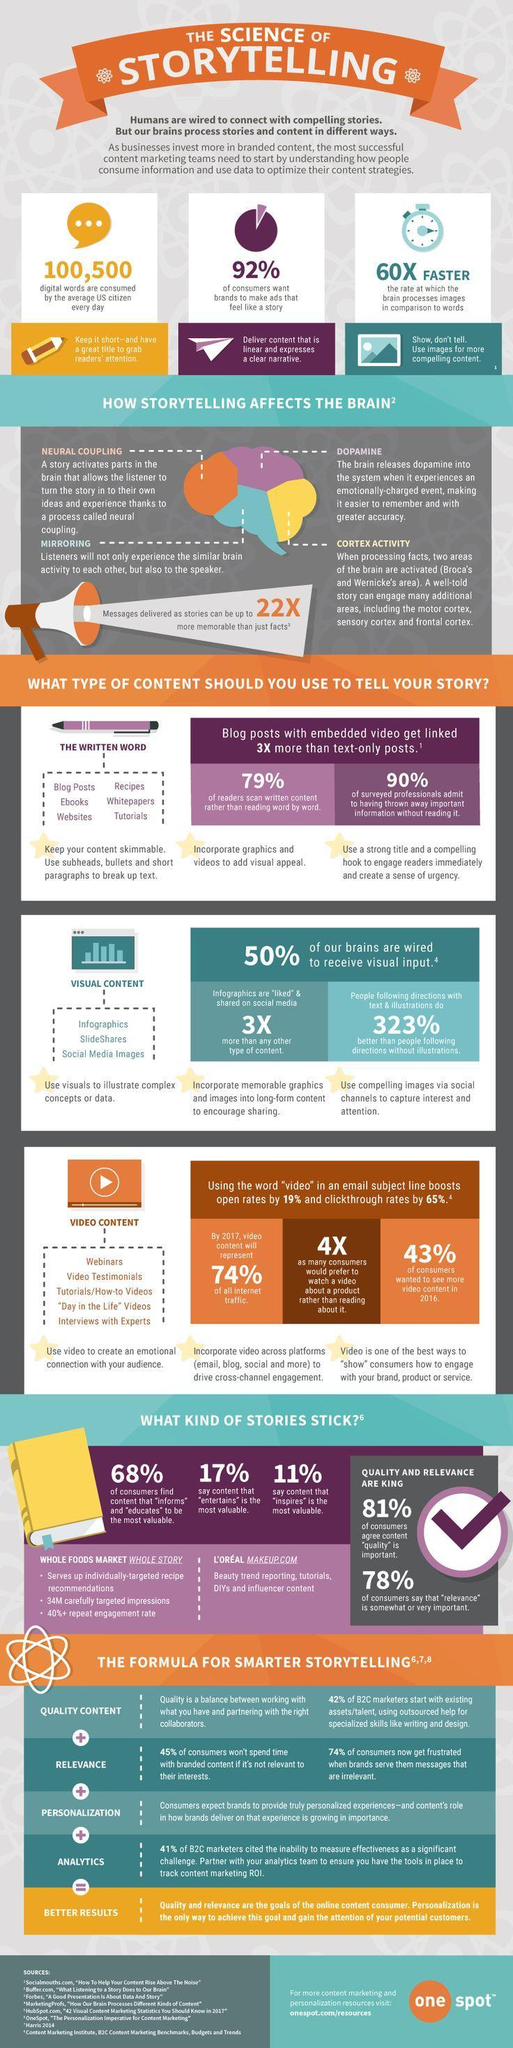Which hormone is released by story telling, Cortex, Neural, or Dopamine?
Answer the question with a short phrase. Dopamine Which content is bound to attract more users, written content, visual content, or video content? video content What percentage of users like stories that convey a message, 11%, 17%, or 68%? 68% 